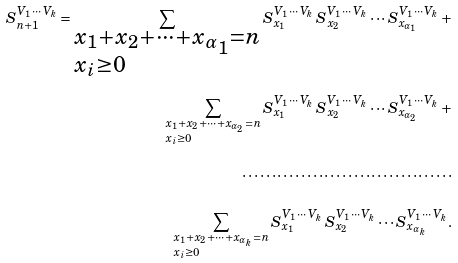<formula> <loc_0><loc_0><loc_500><loc_500>S _ { n + 1 } ^ { V _ { 1 } \, \cdots \, V _ { k } } = \sum _ { \begin{subarray} { c } x _ { 1 } + x _ { 2 } + \cdots + x _ { \alpha _ { 1 } } = n \\ x _ { i } \geq 0 \end{subarray} } { S _ { x _ { 1 } } ^ { V _ { 1 } \, \cdots \, V _ { k } } \, S _ { x _ { 2 } } ^ { V _ { 1 } \, \cdots \, V _ { k } } \cdots S _ { x _ { \alpha _ { 1 } } } ^ { V _ { 1 } \, \cdots \, V _ { k } } } \, + \\ \sum _ { \begin{subarray} { c } x _ { 1 } + x _ { 2 } + \cdots + x _ { \alpha _ { 2 } } = n \\ x _ { i } \geq 0 \end{subarray} } { S _ { x _ { 1 } } ^ { V _ { 1 } \, \cdots \, V _ { k } } \, S _ { x _ { 2 } } ^ { V _ { 1 } \, \cdots \, V _ { k } } \cdots S _ { x _ { \alpha _ { 2 } } } ^ { V _ { 1 } \, \cdots \, V _ { k } } } \, + \\ \cdots \cdots \cdots \cdots \cdots \cdots \cdots \cdots \cdots \cdots \cdots \cdots \\ \sum _ { \begin{subarray} { c } x _ { 1 } + x _ { 2 } + \cdots + x _ { \alpha _ { k } } = n \\ x _ { i } \geq 0 \end{subarray} } { S _ { x _ { 1 } } ^ { V _ { 1 } \, \cdots \, V _ { k } } \, S _ { x _ { 2 } } ^ { V _ { 1 } \, \cdots \, V _ { k } } \cdots S _ { x _ { \alpha _ { k } } } ^ { V _ { 1 } \, \cdots \, V _ { k } } } .</formula> 